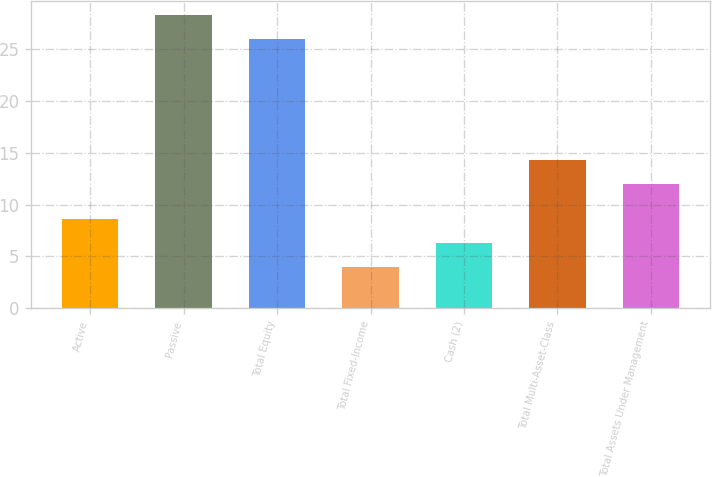<chart> <loc_0><loc_0><loc_500><loc_500><bar_chart><fcel>Active<fcel>Passive<fcel>Total Equity<fcel>Total Fixed-Income<fcel>Cash (2)<fcel>Total Multi-Asset-Class<fcel>Total Assets Under Management<nl><fcel>8.6<fcel>28.3<fcel>26<fcel>4<fcel>6.3<fcel>14.3<fcel>12<nl></chart> 